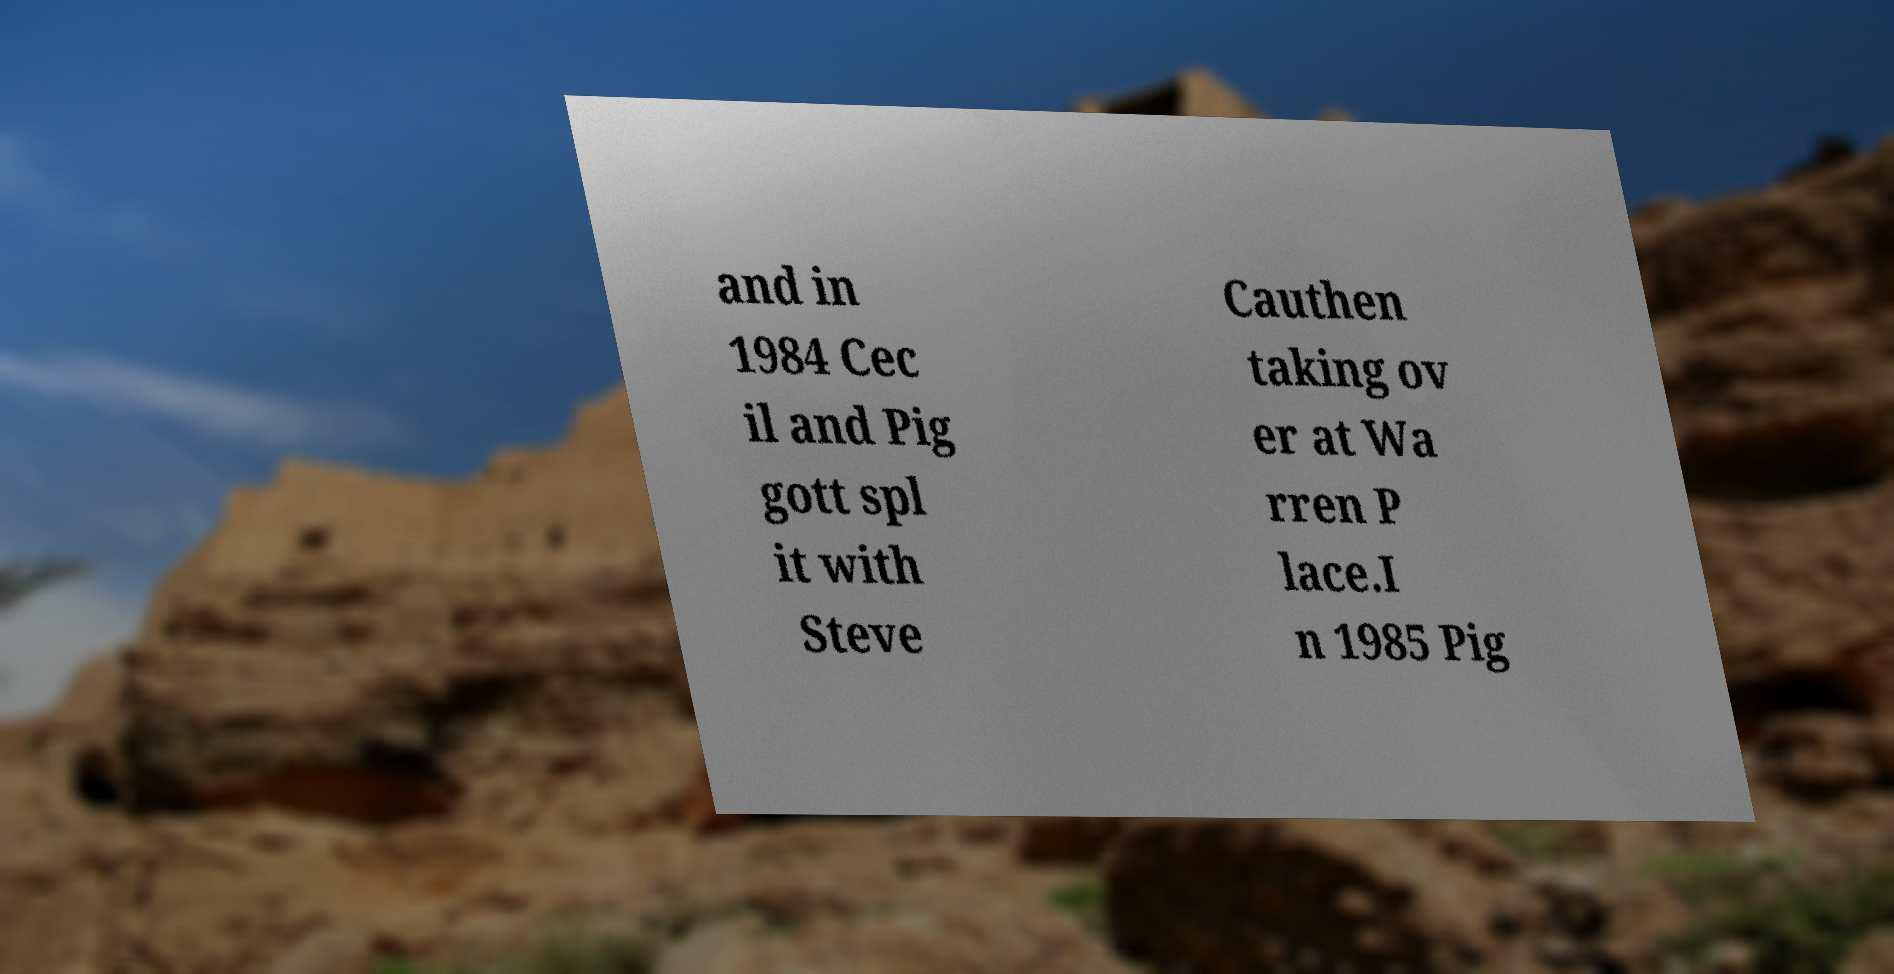I need the written content from this picture converted into text. Can you do that? and in 1984 Cec il and Pig gott spl it with Steve Cauthen taking ov er at Wa rren P lace.I n 1985 Pig 